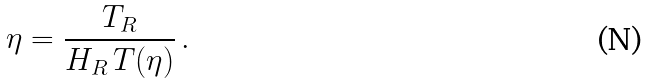Convert formula to latex. <formula><loc_0><loc_0><loc_500><loc_500>\eta = \frac { T _ { R } } { H _ { R } \, T ( \eta ) } \, .</formula> 